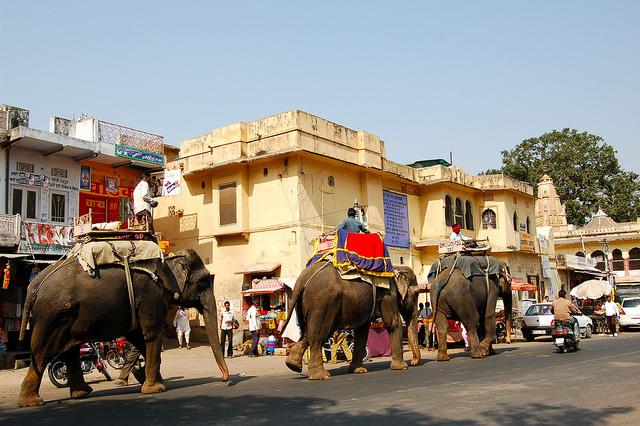Which mode of transport in use here uses less gasoline?

Choices:
A) elephants
B) motorcycle
C) van
D) bus elephants 